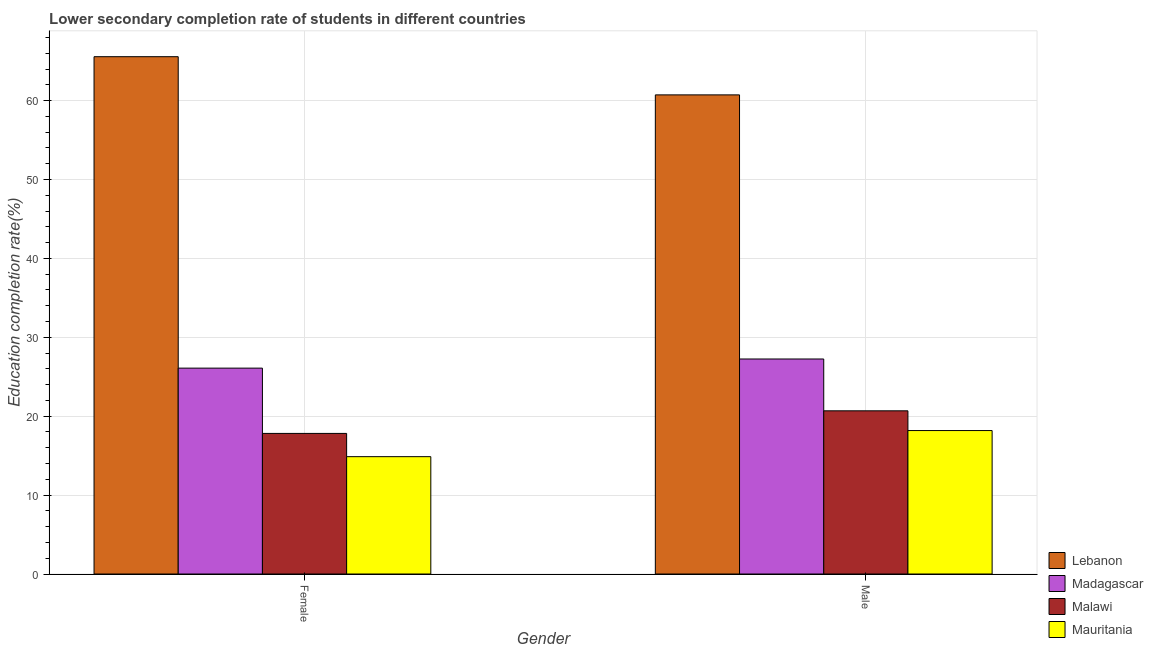Are the number of bars per tick equal to the number of legend labels?
Give a very brief answer. Yes. Are the number of bars on each tick of the X-axis equal?
Provide a short and direct response. Yes. How many bars are there on the 2nd tick from the left?
Offer a terse response. 4. How many bars are there on the 1st tick from the right?
Ensure brevity in your answer.  4. What is the label of the 1st group of bars from the left?
Provide a succinct answer. Female. What is the education completion rate of female students in Madagascar?
Your answer should be very brief. 26.09. Across all countries, what is the maximum education completion rate of female students?
Your response must be concise. 65.57. Across all countries, what is the minimum education completion rate of male students?
Provide a short and direct response. 18.18. In which country was the education completion rate of female students maximum?
Your answer should be compact. Lebanon. In which country was the education completion rate of male students minimum?
Give a very brief answer. Mauritania. What is the total education completion rate of female students in the graph?
Ensure brevity in your answer.  124.36. What is the difference between the education completion rate of male students in Mauritania and that in Malawi?
Give a very brief answer. -2.5. What is the difference between the education completion rate of female students in Madagascar and the education completion rate of male students in Malawi?
Your answer should be very brief. 5.41. What is the average education completion rate of female students per country?
Provide a succinct answer. 31.09. What is the difference between the education completion rate of male students and education completion rate of female students in Lebanon?
Your answer should be compact. -4.84. In how many countries, is the education completion rate of female students greater than 16 %?
Your answer should be very brief. 3. What is the ratio of the education completion rate of male students in Malawi to that in Mauritania?
Your response must be concise. 1.14. Is the education completion rate of female students in Madagascar less than that in Malawi?
Your response must be concise. No. What does the 1st bar from the left in Male represents?
Your answer should be very brief. Lebanon. What does the 2nd bar from the right in Female represents?
Keep it short and to the point. Malawi. How many countries are there in the graph?
Keep it short and to the point. 4. Are the values on the major ticks of Y-axis written in scientific E-notation?
Offer a very short reply. No. Does the graph contain grids?
Your answer should be very brief. Yes. Where does the legend appear in the graph?
Make the answer very short. Bottom right. How many legend labels are there?
Your answer should be very brief. 4. What is the title of the graph?
Offer a terse response. Lower secondary completion rate of students in different countries. What is the label or title of the X-axis?
Give a very brief answer. Gender. What is the label or title of the Y-axis?
Provide a succinct answer. Education completion rate(%). What is the Education completion rate(%) of Lebanon in Female?
Ensure brevity in your answer.  65.57. What is the Education completion rate(%) of Madagascar in Female?
Offer a very short reply. 26.09. What is the Education completion rate(%) in Malawi in Female?
Your answer should be very brief. 17.82. What is the Education completion rate(%) in Mauritania in Female?
Your answer should be very brief. 14.87. What is the Education completion rate(%) of Lebanon in Male?
Your answer should be compact. 60.73. What is the Education completion rate(%) in Madagascar in Male?
Give a very brief answer. 27.25. What is the Education completion rate(%) of Malawi in Male?
Offer a terse response. 20.68. What is the Education completion rate(%) of Mauritania in Male?
Give a very brief answer. 18.18. Across all Gender, what is the maximum Education completion rate(%) in Lebanon?
Make the answer very short. 65.57. Across all Gender, what is the maximum Education completion rate(%) in Madagascar?
Your answer should be compact. 27.25. Across all Gender, what is the maximum Education completion rate(%) of Malawi?
Offer a very short reply. 20.68. Across all Gender, what is the maximum Education completion rate(%) of Mauritania?
Your answer should be very brief. 18.18. Across all Gender, what is the minimum Education completion rate(%) of Lebanon?
Ensure brevity in your answer.  60.73. Across all Gender, what is the minimum Education completion rate(%) in Madagascar?
Provide a short and direct response. 26.09. Across all Gender, what is the minimum Education completion rate(%) of Malawi?
Keep it short and to the point. 17.82. Across all Gender, what is the minimum Education completion rate(%) of Mauritania?
Keep it short and to the point. 14.87. What is the total Education completion rate(%) in Lebanon in the graph?
Your answer should be very brief. 126.3. What is the total Education completion rate(%) in Madagascar in the graph?
Ensure brevity in your answer.  53.35. What is the total Education completion rate(%) of Malawi in the graph?
Provide a succinct answer. 38.5. What is the total Education completion rate(%) in Mauritania in the graph?
Provide a succinct answer. 33.05. What is the difference between the Education completion rate(%) of Lebanon in Female and that in Male?
Offer a terse response. 4.84. What is the difference between the Education completion rate(%) in Madagascar in Female and that in Male?
Your response must be concise. -1.16. What is the difference between the Education completion rate(%) in Malawi in Female and that in Male?
Make the answer very short. -2.86. What is the difference between the Education completion rate(%) in Mauritania in Female and that in Male?
Your answer should be compact. -3.31. What is the difference between the Education completion rate(%) of Lebanon in Female and the Education completion rate(%) of Madagascar in Male?
Provide a succinct answer. 38.32. What is the difference between the Education completion rate(%) in Lebanon in Female and the Education completion rate(%) in Malawi in Male?
Make the answer very short. 44.89. What is the difference between the Education completion rate(%) in Lebanon in Female and the Education completion rate(%) in Mauritania in Male?
Offer a very short reply. 47.39. What is the difference between the Education completion rate(%) of Madagascar in Female and the Education completion rate(%) of Malawi in Male?
Make the answer very short. 5.41. What is the difference between the Education completion rate(%) of Madagascar in Female and the Education completion rate(%) of Mauritania in Male?
Your response must be concise. 7.91. What is the difference between the Education completion rate(%) in Malawi in Female and the Education completion rate(%) in Mauritania in Male?
Make the answer very short. -0.36. What is the average Education completion rate(%) in Lebanon per Gender?
Offer a terse response. 63.15. What is the average Education completion rate(%) in Madagascar per Gender?
Give a very brief answer. 26.67. What is the average Education completion rate(%) of Malawi per Gender?
Ensure brevity in your answer.  19.25. What is the average Education completion rate(%) of Mauritania per Gender?
Your answer should be very brief. 16.53. What is the difference between the Education completion rate(%) in Lebanon and Education completion rate(%) in Madagascar in Female?
Ensure brevity in your answer.  39.48. What is the difference between the Education completion rate(%) in Lebanon and Education completion rate(%) in Malawi in Female?
Offer a terse response. 47.75. What is the difference between the Education completion rate(%) in Lebanon and Education completion rate(%) in Mauritania in Female?
Ensure brevity in your answer.  50.7. What is the difference between the Education completion rate(%) of Madagascar and Education completion rate(%) of Malawi in Female?
Your answer should be compact. 8.28. What is the difference between the Education completion rate(%) in Madagascar and Education completion rate(%) in Mauritania in Female?
Offer a terse response. 11.22. What is the difference between the Education completion rate(%) of Malawi and Education completion rate(%) of Mauritania in Female?
Your answer should be compact. 2.95. What is the difference between the Education completion rate(%) of Lebanon and Education completion rate(%) of Madagascar in Male?
Your response must be concise. 33.48. What is the difference between the Education completion rate(%) of Lebanon and Education completion rate(%) of Malawi in Male?
Your answer should be very brief. 40.05. What is the difference between the Education completion rate(%) of Lebanon and Education completion rate(%) of Mauritania in Male?
Your answer should be very brief. 42.55. What is the difference between the Education completion rate(%) of Madagascar and Education completion rate(%) of Malawi in Male?
Ensure brevity in your answer.  6.57. What is the difference between the Education completion rate(%) of Madagascar and Education completion rate(%) of Mauritania in Male?
Make the answer very short. 9.07. What is the difference between the Education completion rate(%) of Malawi and Education completion rate(%) of Mauritania in Male?
Make the answer very short. 2.5. What is the ratio of the Education completion rate(%) in Lebanon in Female to that in Male?
Provide a succinct answer. 1.08. What is the ratio of the Education completion rate(%) of Madagascar in Female to that in Male?
Ensure brevity in your answer.  0.96. What is the ratio of the Education completion rate(%) in Malawi in Female to that in Male?
Offer a terse response. 0.86. What is the ratio of the Education completion rate(%) in Mauritania in Female to that in Male?
Provide a succinct answer. 0.82. What is the difference between the highest and the second highest Education completion rate(%) in Lebanon?
Your response must be concise. 4.84. What is the difference between the highest and the second highest Education completion rate(%) in Madagascar?
Your answer should be compact. 1.16. What is the difference between the highest and the second highest Education completion rate(%) of Malawi?
Provide a short and direct response. 2.86. What is the difference between the highest and the second highest Education completion rate(%) of Mauritania?
Offer a very short reply. 3.31. What is the difference between the highest and the lowest Education completion rate(%) in Lebanon?
Offer a terse response. 4.84. What is the difference between the highest and the lowest Education completion rate(%) of Madagascar?
Provide a short and direct response. 1.16. What is the difference between the highest and the lowest Education completion rate(%) in Malawi?
Make the answer very short. 2.86. What is the difference between the highest and the lowest Education completion rate(%) of Mauritania?
Ensure brevity in your answer.  3.31. 